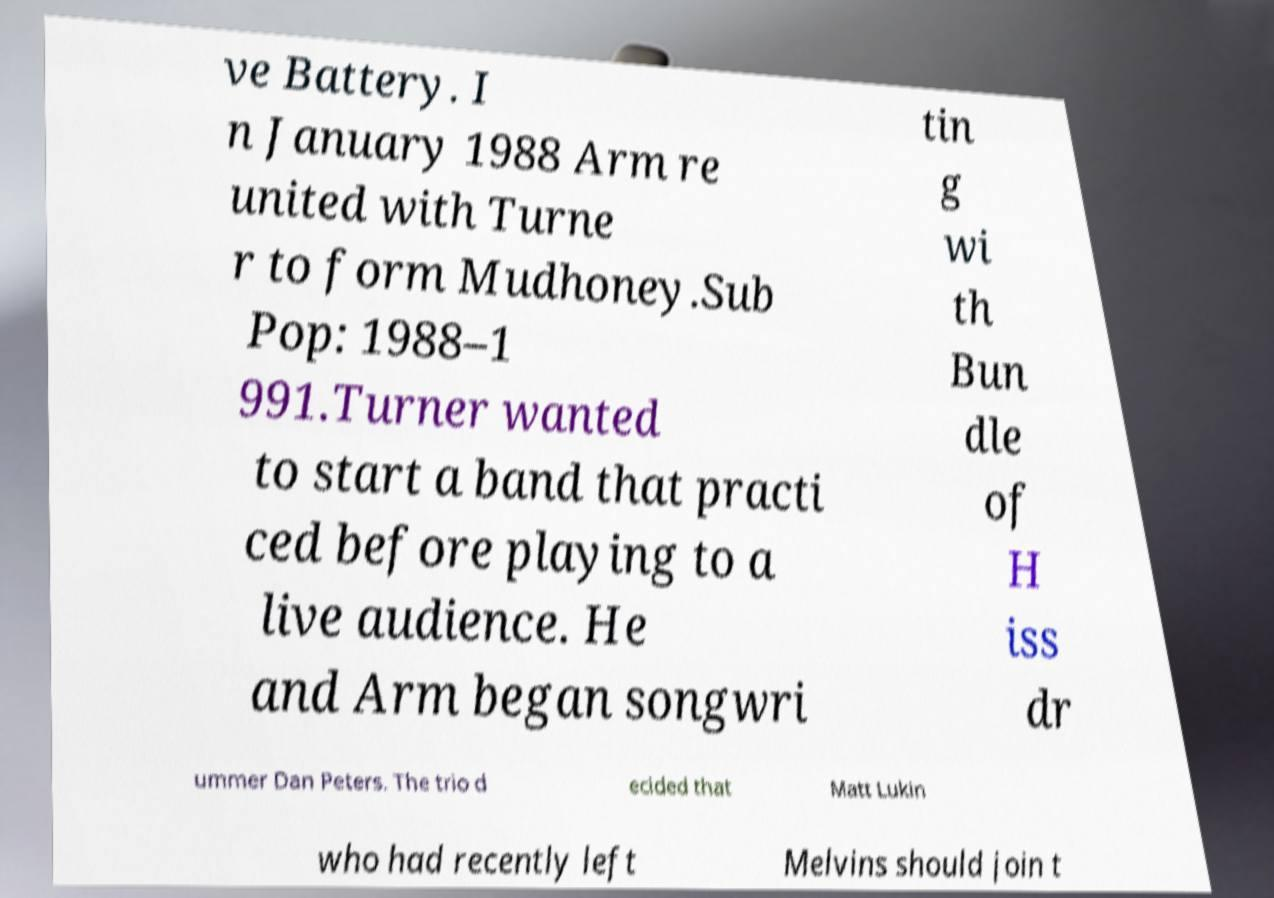Can you read and provide the text displayed in the image?This photo seems to have some interesting text. Can you extract and type it out for me? ve Battery. I n January 1988 Arm re united with Turne r to form Mudhoney.Sub Pop: 1988–1 991.Turner wanted to start a band that practi ced before playing to a live audience. He and Arm began songwri tin g wi th Bun dle of H iss dr ummer Dan Peters. The trio d ecided that Matt Lukin who had recently left Melvins should join t 